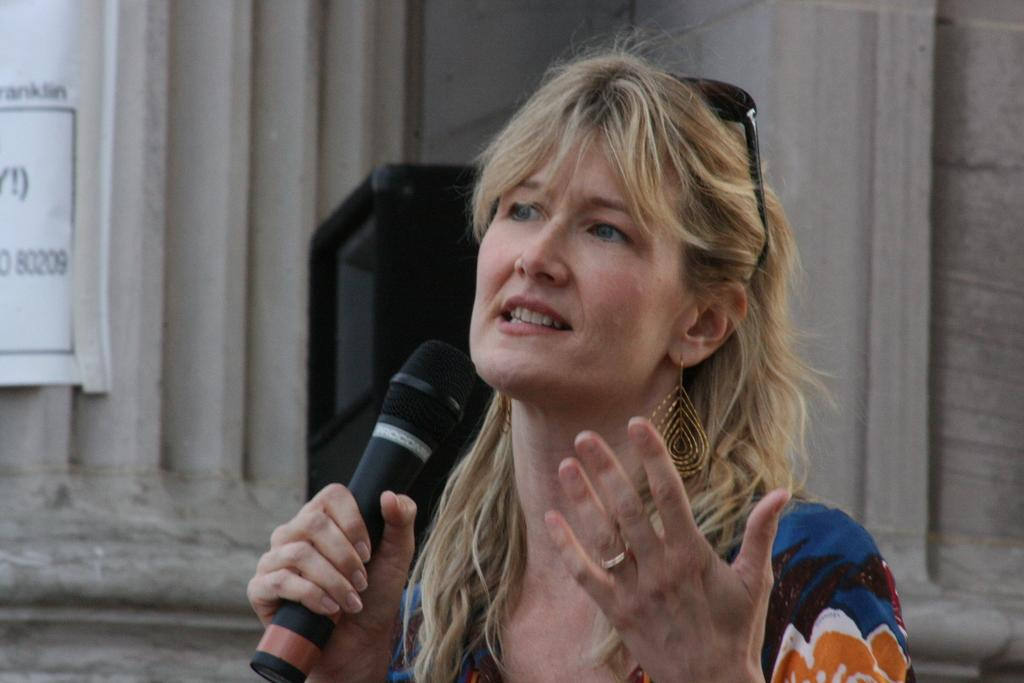What is the main subject of the image? There is a person in the image. What is the person holding in the image? The person is holding a mic. Can you describe any additional features in the image? There is a white color banner attached to the wall in the image. How does the pancake affect the person's performance in the image? There is no pancake present in the image, so it cannot affect the person's performance. 